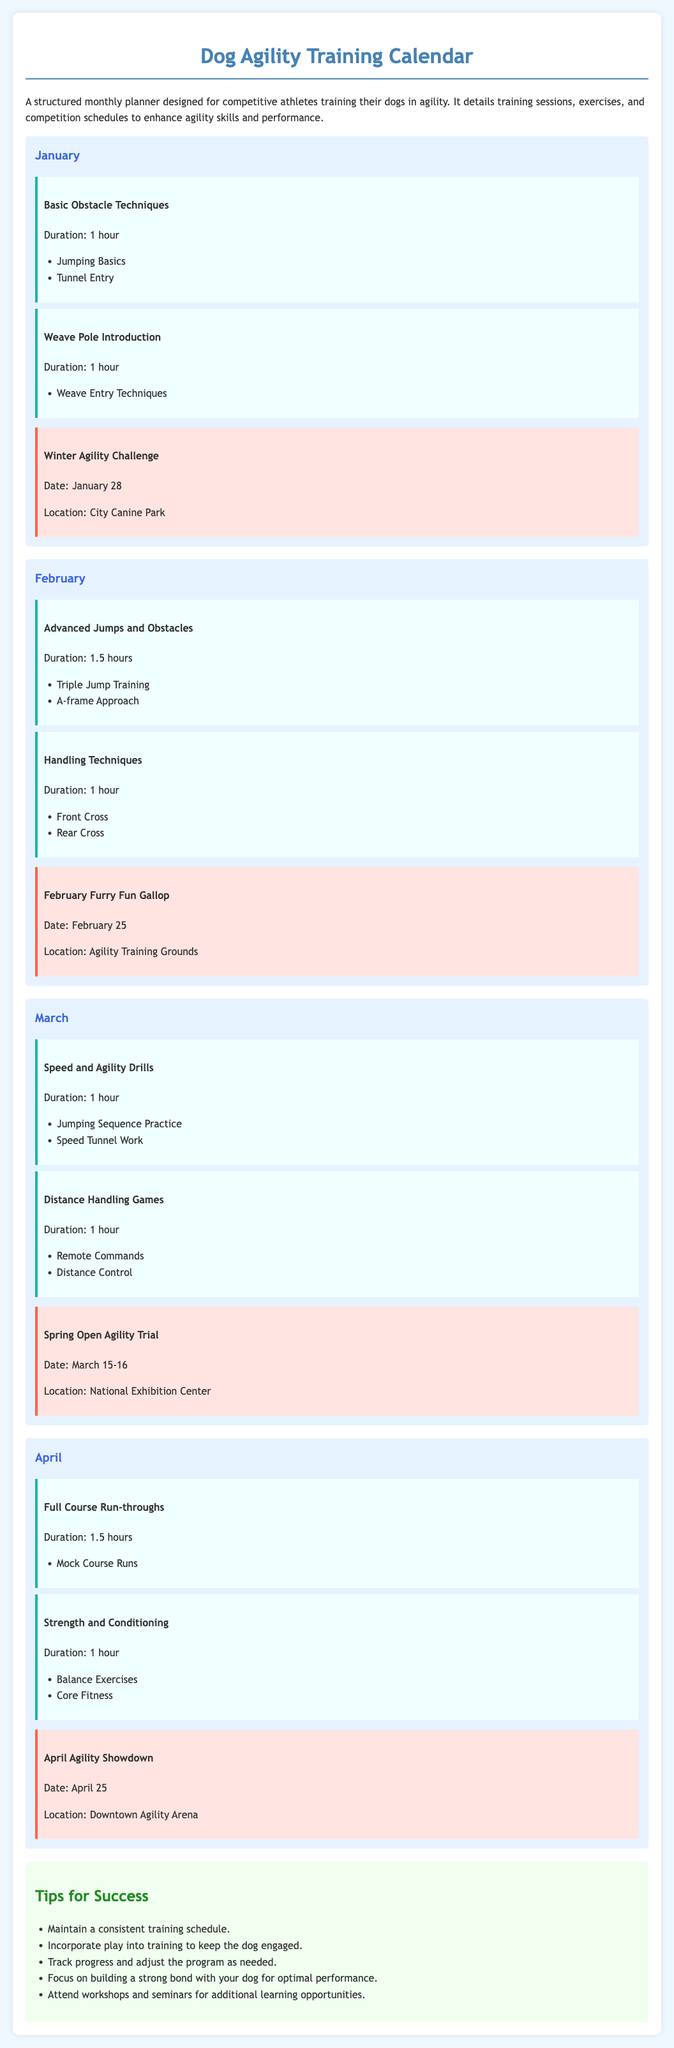What is the duration of the "Basic Obstacle Techniques" session? The duration of the "Basic Obstacle Techniques" session is mentioned as 1 hour in the document.
Answer: 1 hour When is the "February Furry Fun Gallop" competition scheduled? The date for the "February Furry Fun Gallop" competition is stated as February 25.
Answer: February 25 What is one of the exercises in the "Weave Pole Introduction" session? The document lists "Weave Entry Techniques" as an exercise in the "Weave Pole Introduction" session.
Answer: Weave Entry Techniques How long is the "Full Course Run-throughs" session? The duration of the "Full Course Run-throughs" session is specified as 1.5 hours.
Answer: 1.5 hours What color background is used for the "competition" sections? The background color for the "competition" sections is described as #ffe4e1 in the document.
Answer: #ffe4e1 What are the dates for the "Spring Open Agility Trial"? The dates for the "Spring Open Agility Trial" are provided as March 15-16.
Answer: March 15-16 What type of games are included in the "Distance Handling Games" session? The document indicates that "Remote Commands" and "Distance Control" are included in the "Distance Handling Games" session.
Answer: Remote Commands, Distance Control What theme is emphasized in the "Tips for Success"? The overall theme in the "Tips for Success" focuses on maintaining a consistent training schedule.
Answer: Consistent training schedule 